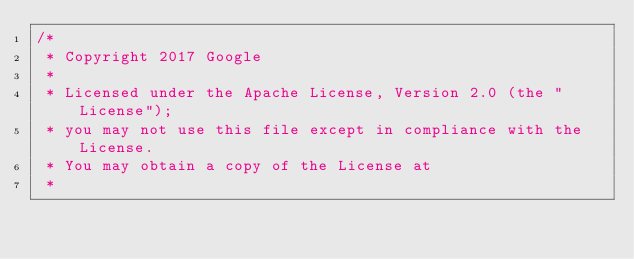Convert code to text. <code><loc_0><loc_0><loc_500><loc_500><_ObjectiveC_>/*
 * Copyright 2017 Google
 *
 * Licensed under the Apache License, Version 2.0 (the "License");
 * you may not use this file except in compliance with the License.
 * You may obtain a copy of the License at
 *</code> 